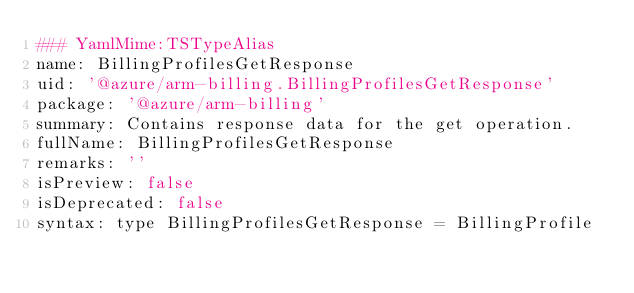<code> <loc_0><loc_0><loc_500><loc_500><_YAML_>### YamlMime:TSTypeAlias
name: BillingProfilesGetResponse
uid: '@azure/arm-billing.BillingProfilesGetResponse'
package: '@azure/arm-billing'
summary: Contains response data for the get operation.
fullName: BillingProfilesGetResponse
remarks: ''
isPreview: false
isDeprecated: false
syntax: type BillingProfilesGetResponse = BillingProfile
</code> 